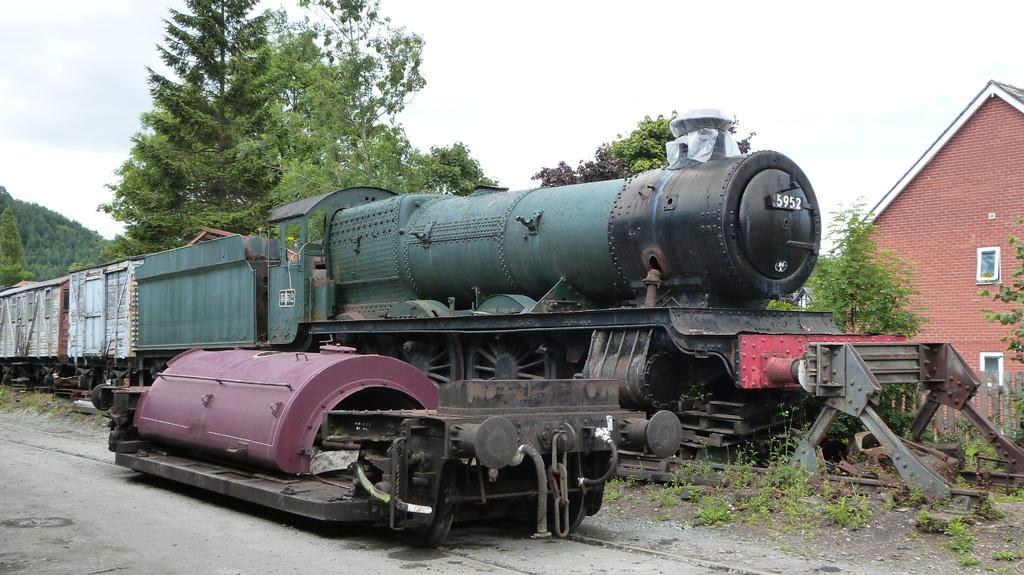What is the main subject of the image? The main subject of the image is a train. Where is the train located in the image? The train is standing on a railway track. What else can be seen in the image besides the train? There is an engine machine in the image, and it is on the ground. What can be seen in the background of the image? There is a building and trees in the background of the image. What type of toy can be seen on the train in the image? There are no toys present on the train in the image. How does the skate help the train move faster in the image? There is no skate present in the image, and the train's movement is not affected by any skate. 